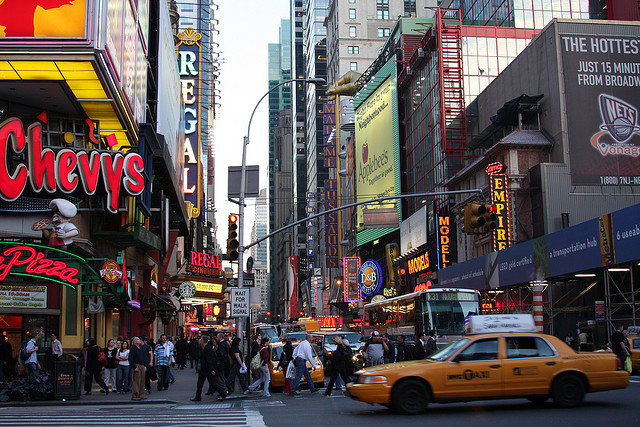Can you describe the mood captured in this bustling city scene? The image depicts a vibrant and dynamic urban atmosphere, bustling with people and cars. The brightly lit signs and advertisements add a lively and energetic mood to the street scene, reflecting a typical busy day in a bustling city. 